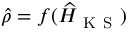<formula> <loc_0><loc_0><loc_500><loc_500>\widehat { \rho } = f ( \widehat { H } _ { K S } )</formula> 